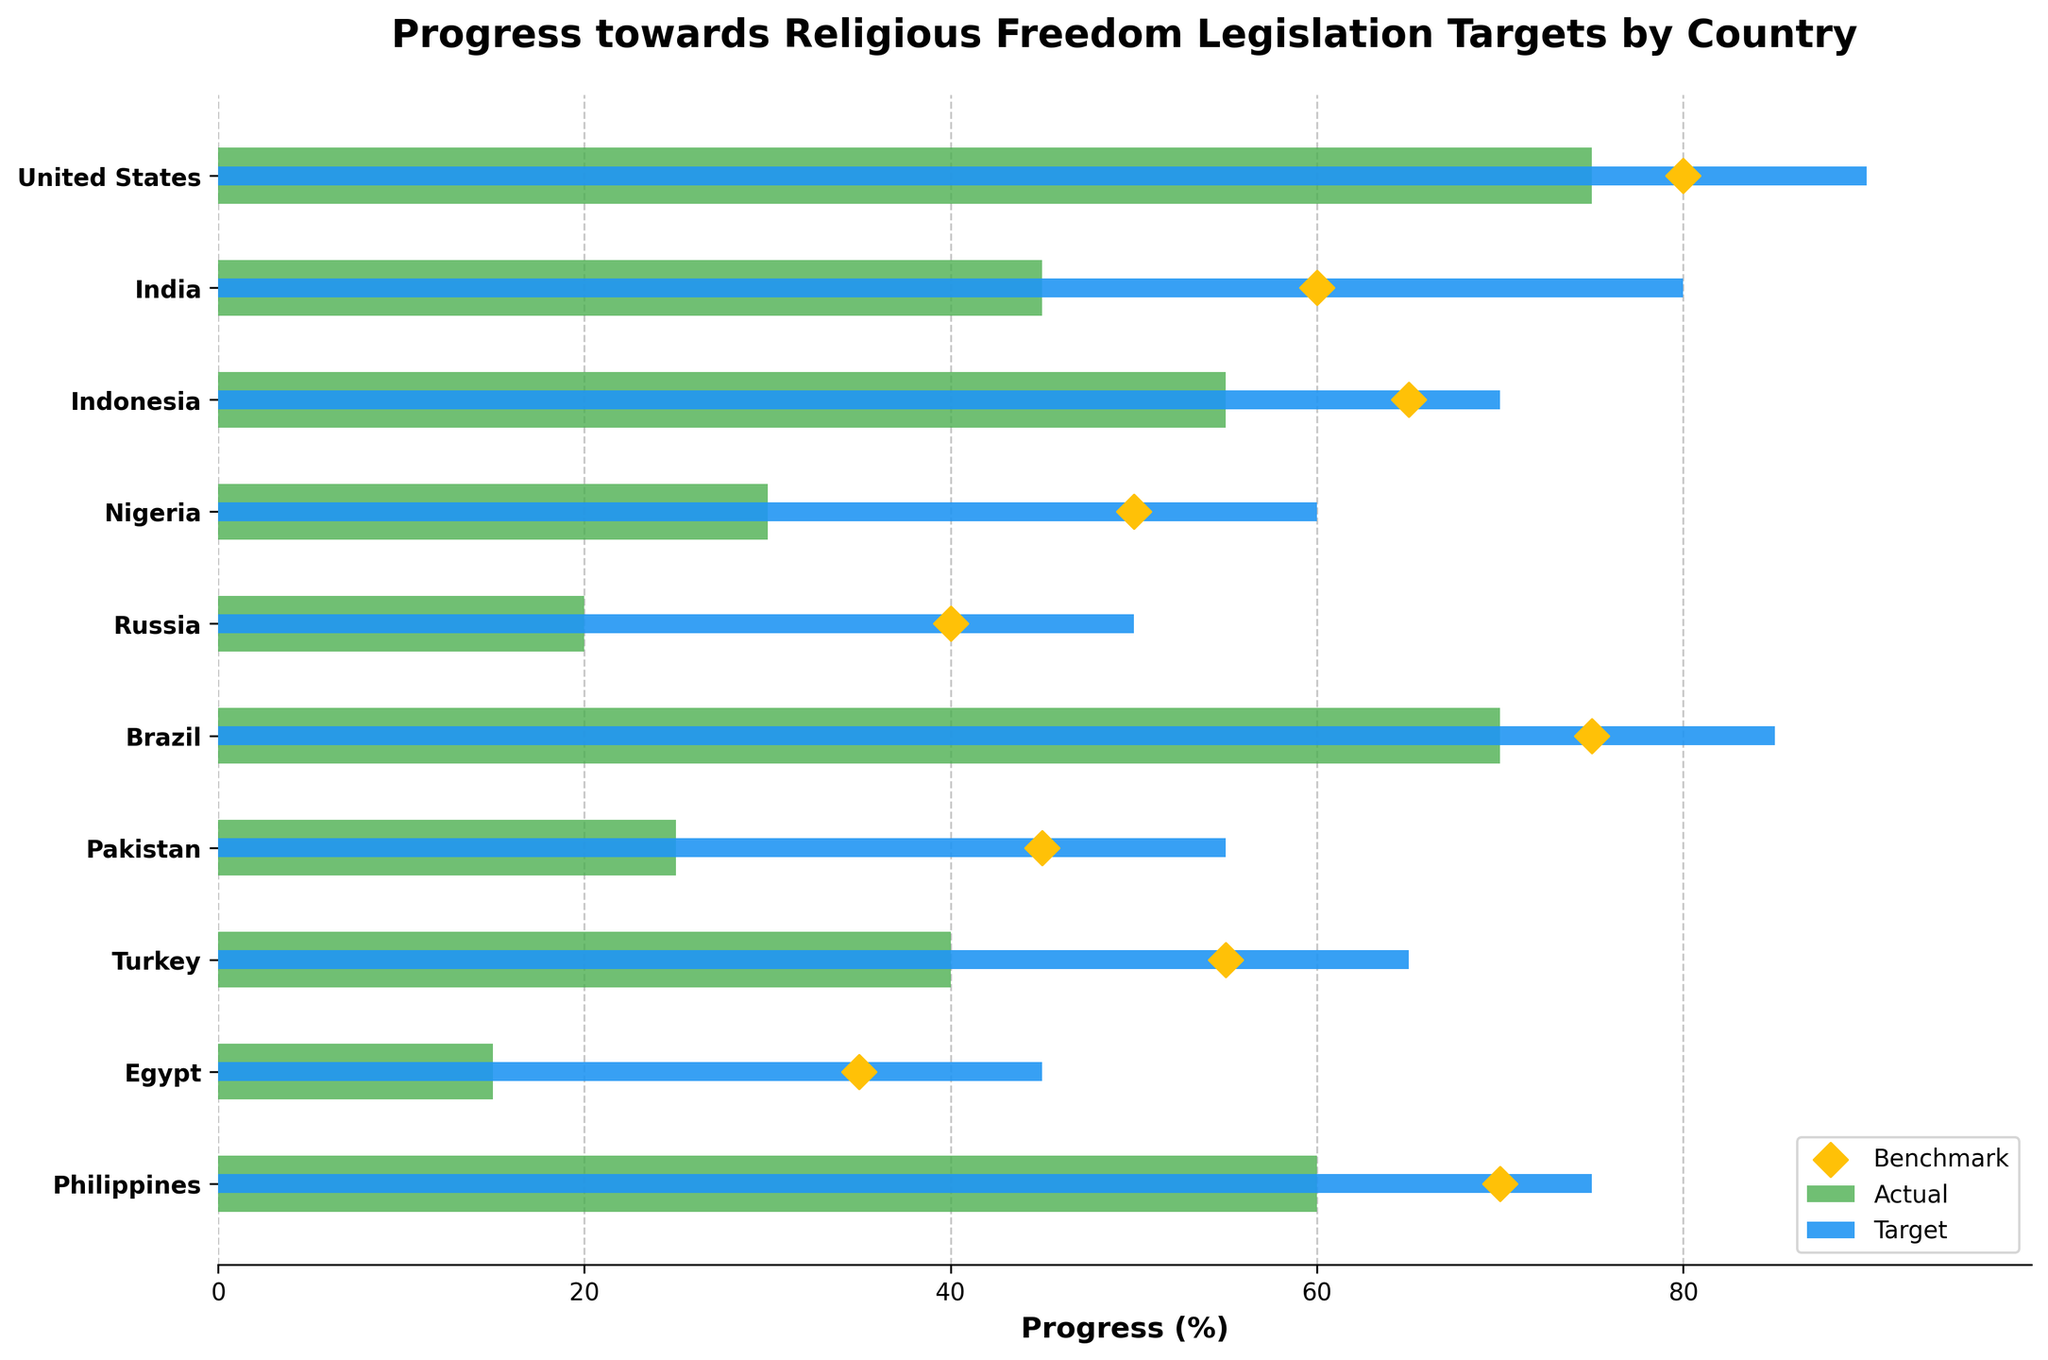What is the title of the figure? The title is usually displayed prominently at the top of the figure. In this case, it reads "Progress towards Religious Freedom Legislation Targets by Country".
Answer: Progress towards Religious Freedom Legislation Targets by Country Which country has the highest actual progress percentage? To find this, look at the lengths of the green bars for each country. The United States has the longest green bar, indicating the highest actual progress.
Answer: United States For India, what is the difference between the target percentage and the actual percentage? To calculate this, subtract the actual percentage from the target percentage for India: 80 (target) - 45 (actual) = 35.
Answer: 35 Which country has the smallest difference between the benchmark and the actual progress? To find this, look for the smallest distance between the benchmark (yellow diamond) and the actual progress (green bar). The Philippines shows the smallest difference between these two.
Answer: Philippines What is the benchmark percentage for Turkey? The benchmark percentage is indicated by the yellow diamond for each country. For Turkey, this diamond is positioned at 55%.
Answer: 55% How does Brazil's actual progress compare to Nigeria's actual progress? Brazil's actual progress (green bar) is higher at 70%, whereas Nigeria's actual progress is lower at 30%.
Answer: Brazil's actual progress is higher than Nigeria's Which countries have actual progress percentages below their benchmarks? Countries with green bars shorter than their yellow diamonds indicate actual progress below benchmarks. These countries are India, Indonesia, Nigeria, Russia, Pakistan, Turkey, and Egypt.
Answer: India, Indonesia, Nigeria, Russia, Pakistan, Turkey, Egypt What is the mean of the target percentages for the given countries? Add all target percentages and divide by the number of countries: (90 + 80 + 70 + 60 + 50 + 85 + 55 + 65 + 45 + 75) / 10 = 67.5.
Answer: 67.5 Which country has the lowest actual progress relative to its target? Calculate the difference between the actual percentage and the target percentage for each country, then identify the largest negative difference. Russia has the largest negative difference, with a target of 50% and an actual progress of 20%, resulting in -30.
Answer: Russia 